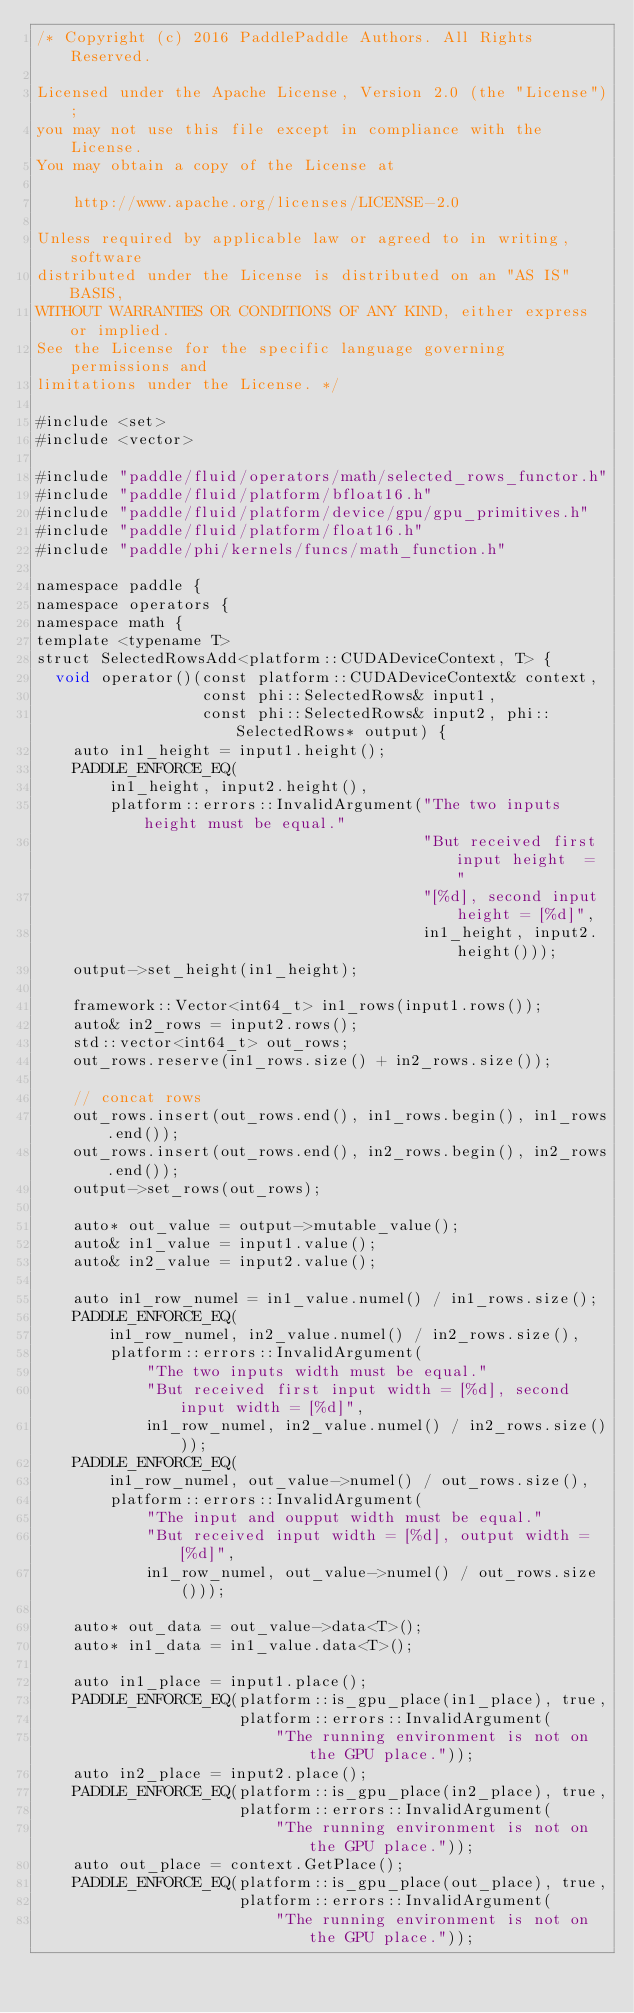<code> <loc_0><loc_0><loc_500><loc_500><_Cuda_>/* Copyright (c) 2016 PaddlePaddle Authors. All Rights Reserved.

Licensed under the Apache License, Version 2.0 (the "License");
you may not use this file except in compliance with the License.
You may obtain a copy of the License at

    http://www.apache.org/licenses/LICENSE-2.0

Unless required by applicable law or agreed to in writing, software
distributed under the License is distributed on an "AS IS" BASIS,
WITHOUT WARRANTIES OR CONDITIONS OF ANY KIND, either express or implied.
See the License for the specific language governing permissions and
limitations under the License. */

#include <set>
#include <vector>

#include "paddle/fluid/operators/math/selected_rows_functor.h"
#include "paddle/fluid/platform/bfloat16.h"
#include "paddle/fluid/platform/device/gpu/gpu_primitives.h"
#include "paddle/fluid/platform/float16.h"
#include "paddle/phi/kernels/funcs/math_function.h"

namespace paddle {
namespace operators {
namespace math {
template <typename T>
struct SelectedRowsAdd<platform::CUDADeviceContext, T> {
  void operator()(const platform::CUDADeviceContext& context,
                  const phi::SelectedRows& input1,
                  const phi::SelectedRows& input2, phi::SelectedRows* output) {
    auto in1_height = input1.height();
    PADDLE_ENFORCE_EQ(
        in1_height, input2.height(),
        platform::errors::InvalidArgument("The two inputs height must be equal."
                                          "But received first input height  = "
                                          "[%d], second input height = [%d]",
                                          in1_height, input2.height()));
    output->set_height(in1_height);

    framework::Vector<int64_t> in1_rows(input1.rows());
    auto& in2_rows = input2.rows();
    std::vector<int64_t> out_rows;
    out_rows.reserve(in1_rows.size() + in2_rows.size());

    // concat rows
    out_rows.insert(out_rows.end(), in1_rows.begin(), in1_rows.end());
    out_rows.insert(out_rows.end(), in2_rows.begin(), in2_rows.end());
    output->set_rows(out_rows);

    auto* out_value = output->mutable_value();
    auto& in1_value = input1.value();
    auto& in2_value = input2.value();

    auto in1_row_numel = in1_value.numel() / in1_rows.size();
    PADDLE_ENFORCE_EQ(
        in1_row_numel, in2_value.numel() / in2_rows.size(),
        platform::errors::InvalidArgument(
            "The two inputs width must be equal."
            "But received first input width = [%d], second input width = [%d]",
            in1_row_numel, in2_value.numel() / in2_rows.size()));
    PADDLE_ENFORCE_EQ(
        in1_row_numel, out_value->numel() / out_rows.size(),
        platform::errors::InvalidArgument(
            "The input and oupput width must be equal."
            "But received input width = [%d], output width = [%d]",
            in1_row_numel, out_value->numel() / out_rows.size()));

    auto* out_data = out_value->data<T>();
    auto* in1_data = in1_value.data<T>();

    auto in1_place = input1.place();
    PADDLE_ENFORCE_EQ(platform::is_gpu_place(in1_place), true,
                      platform::errors::InvalidArgument(
                          "The running environment is not on the GPU place."));
    auto in2_place = input2.place();
    PADDLE_ENFORCE_EQ(platform::is_gpu_place(in2_place), true,
                      platform::errors::InvalidArgument(
                          "The running environment is not on the GPU place."));
    auto out_place = context.GetPlace();
    PADDLE_ENFORCE_EQ(platform::is_gpu_place(out_place), true,
                      platform::errors::InvalidArgument(
                          "The running environment is not on the GPU place."));
</code> 